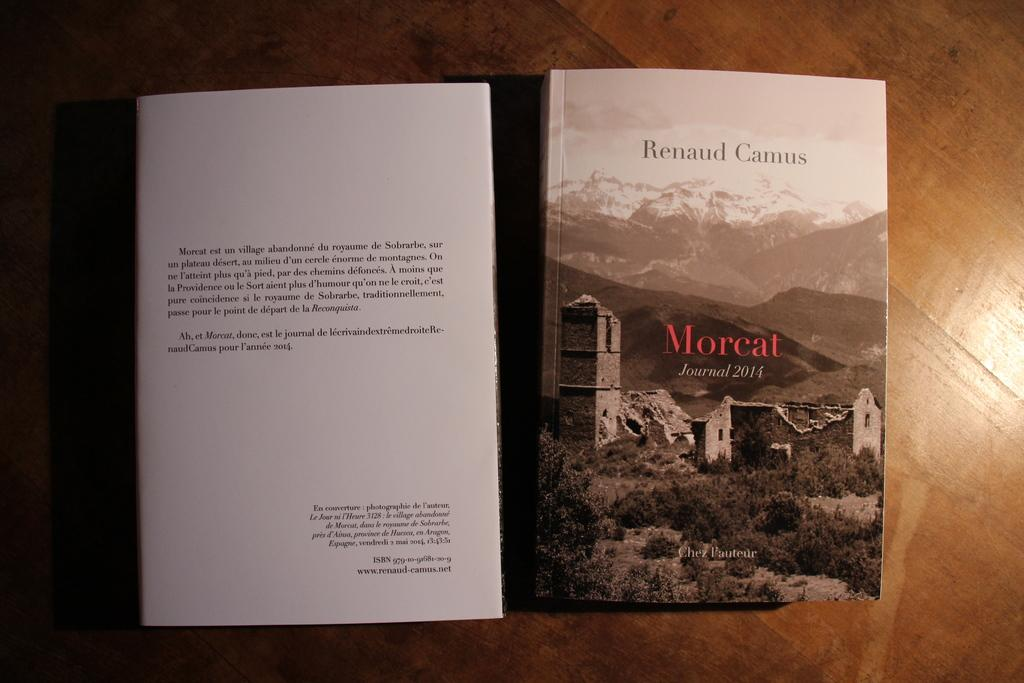<image>
Share a concise interpretation of the image provided. A scenic view is on the front of the Morcat journal 2014. 